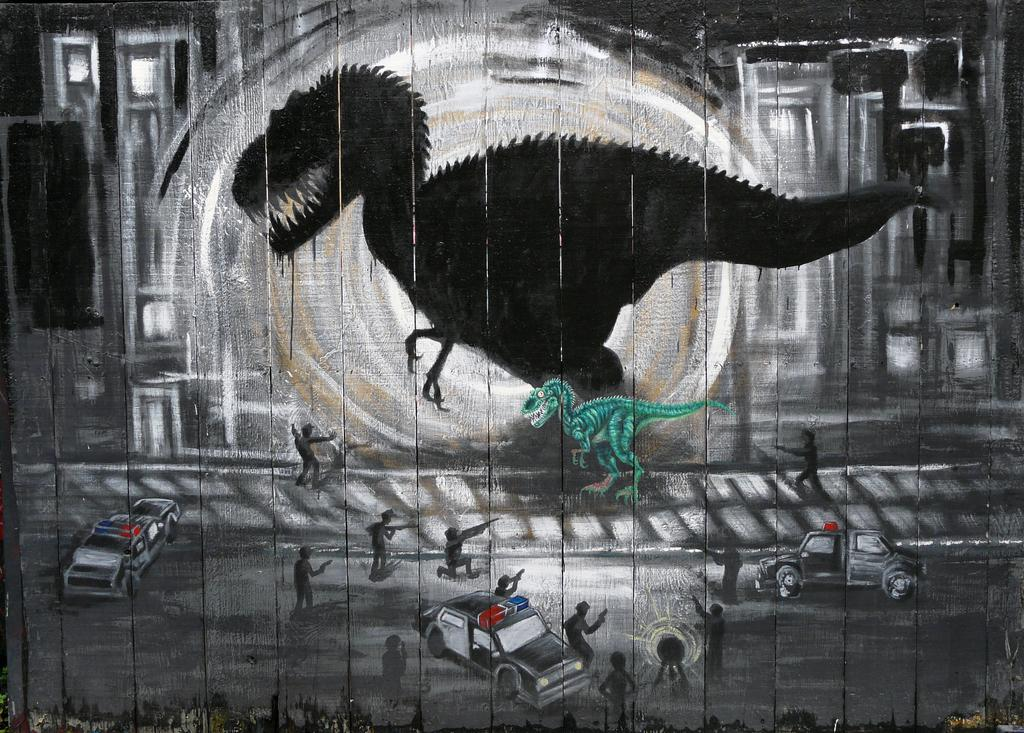What is on the wall in the image? There is graffiti on the wall in the image. What subjects are depicted in the graffiti? The graffiti depicts animals, people, and vehicles. What type of lettuce is being used as a spy in the image? There is no lettuce or spy present in the image; it features graffiti depicting animals, people, and vehicles. 